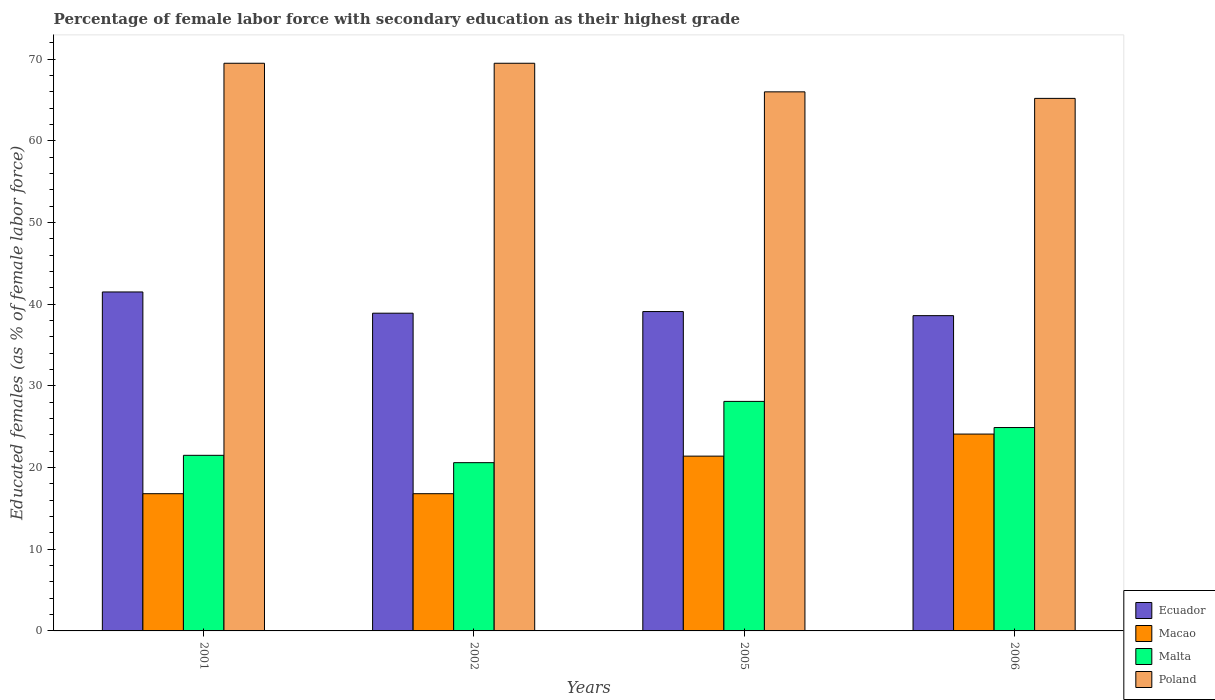How many different coloured bars are there?
Keep it short and to the point. 4. How many groups of bars are there?
Make the answer very short. 4. How many bars are there on the 2nd tick from the left?
Provide a succinct answer. 4. How many bars are there on the 1st tick from the right?
Offer a terse response. 4. What is the percentage of female labor force with secondary education in Ecuador in 2005?
Ensure brevity in your answer.  39.1. Across all years, what is the maximum percentage of female labor force with secondary education in Macao?
Your answer should be compact. 24.1. Across all years, what is the minimum percentage of female labor force with secondary education in Malta?
Your answer should be compact. 20.6. What is the total percentage of female labor force with secondary education in Ecuador in the graph?
Your answer should be compact. 158.1. What is the difference between the percentage of female labor force with secondary education in Poland in 2001 and that in 2002?
Your answer should be compact. 0. What is the difference between the percentage of female labor force with secondary education in Malta in 2005 and the percentage of female labor force with secondary education in Poland in 2001?
Make the answer very short. -41.4. What is the average percentage of female labor force with secondary education in Macao per year?
Make the answer very short. 19.77. In the year 2006, what is the difference between the percentage of female labor force with secondary education in Poland and percentage of female labor force with secondary education in Ecuador?
Offer a very short reply. 26.6. In how many years, is the percentage of female labor force with secondary education in Malta greater than 24 %?
Your answer should be compact. 2. What is the ratio of the percentage of female labor force with secondary education in Malta in 2002 to that in 2005?
Offer a very short reply. 0.73. What is the difference between the highest and the second highest percentage of female labor force with secondary education in Macao?
Ensure brevity in your answer.  2.7. What is the difference between the highest and the lowest percentage of female labor force with secondary education in Ecuador?
Your answer should be very brief. 2.9. Is the sum of the percentage of female labor force with secondary education in Malta in 2001 and 2002 greater than the maximum percentage of female labor force with secondary education in Macao across all years?
Ensure brevity in your answer.  Yes. Is it the case that in every year, the sum of the percentage of female labor force with secondary education in Macao and percentage of female labor force with secondary education in Poland is greater than the sum of percentage of female labor force with secondary education in Ecuador and percentage of female labor force with secondary education in Malta?
Give a very brief answer. Yes. What does the 1st bar from the left in 2001 represents?
Give a very brief answer. Ecuador. What does the 1st bar from the right in 2005 represents?
Provide a short and direct response. Poland. How many bars are there?
Ensure brevity in your answer.  16. Are all the bars in the graph horizontal?
Make the answer very short. No. How many years are there in the graph?
Keep it short and to the point. 4. What is the difference between two consecutive major ticks on the Y-axis?
Your response must be concise. 10. Where does the legend appear in the graph?
Make the answer very short. Bottom right. How are the legend labels stacked?
Ensure brevity in your answer.  Vertical. What is the title of the graph?
Make the answer very short. Percentage of female labor force with secondary education as their highest grade. What is the label or title of the X-axis?
Offer a very short reply. Years. What is the label or title of the Y-axis?
Your response must be concise. Educated females (as % of female labor force). What is the Educated females (as % of female labor force) of Ecuador in 2001?
Make the answer very short. 41.5. What is the Educated females (as % of female labor force) in Macao in 2001?
Your answer should be compact. 16.8. What is the Educated females (as % of female labor force) of Malta in 2001?
Offer a very short reply. 21.5. What is the Educated females (as % of female labor force) of Poland in 2001?
Your response must be concise. 69.5. What is the Educated females (as % of female labor force) in Ecuador in 2002?
Your response must be concise. 38.9. What is the Educated females (as % of female labor force) in Macao in 2002?
Make the answer very short. 16.8. What is the Educated females (as % of female labor force) in Malta in 2002?
Keep it short and to the point. 20.6. What is the Educated females (as % of female labor force) of Poland in 2002?
Provide a succinct answer. 69.5. What is the Educated females (as % of female labor force) of Ecuador in 2005?
Offer a very short reply. 39.1. What is the Educated females (as % of female labor force) in Macao in 2005?
Offer a terse response. 21.4. What is the Educated females (as % of female labor force) in Malta in 2005?
Give a very brief answer. 28.1. What is the Educated females (as % of female labor force) of Poland in 2005?
Offer a very short reply. 66. What is the Educated females (as % of female labor force) of Ecuador in 2006?
Give a very brief answer. 38.6. What is the Educated females (as % of female labor force) in Macao in 2006?
Your response must be concise. 24.1. What is the Educated females (as % of female labor force) of Malta in 2006?
Provide a succinct answer. 24.9. What is the Educated females (as % of female labor force) of Poland in 2006?
Ensure brevity in your answer.  65.2. Across all years, what is the maximum Educated females (as % of female labor force) of Ecuador?
Your answer should be very brief. 41.5. Across all years, what is the maximum Educated females (as % of female labor force) of Macao?
Make the answer very short. 24.1. Across all years, what is the maximum Educated females (as % of female labor force) of Malta?
Offer a terse response. 28.1. Across all years, what is the maximum Educated females (as % of female labor force) in Poland?
Provide a succinct answer. 69.5. Across all years, what is the minimum Educated females (as % of female labor force) in Ecuador?
Provide a succinct answer. 38.6. Across all years, what is the minimum Educated females (as % of female labor force) in Macao?
Provide a short and direct response. 16.8. Across all years, what is the minimum Educated females (as % of female labor force) of Malta?
Your answer should be compact. 20.6. Across all years, what is the minimum Educated females (as % of female labor force) in Poland?
Offer a terse response. 65.2. What is the total Educated females (as % of female labor force) in Ecuador in the graph?
Provide a succinct answer. 158.1. What is the total Educated females (as % of female labor force) in Macao in the graph?
Keep it short and to the point. 79.1. What is the total Educated females (as % of female labor force) in Malta in the graph?
Your answer should be very brief. 95.1. What is the total Educated females (as % of female labor force) of Poland in the graph?
Offer a very short reply. 270.2. What is the difference between the Educated females (as % of female labor force) in Ecuador in 2001 and that in 2005?
Your answer should be compact. 2.4. What is the difference between the Educated females (as % of female labor force) of Malta in 2001 and that in 2005?
Your answer should be very brief. -6.6. What is the difference between the Educated females (as % of female labor force) in Poland in 2001 and that in 2005?
Your response must be concise. 3.5. What is the difference between the Educated females (as % of female labor force) in Ecuador in 2001 and that in 2006?
Provide a succinct answer. 2.9. What is the difference between the Educated females (as % of female labor force) in Poland in 2001 and that in 2006?
Make the answer very short. 4.3. What is the difference between the Educated females (as % of female labor force) in Macao in 2002 and that in 2005?
Your response must be concise. -4.6. What is the difference between the Educated females (as % of female labor force) in Malta in 2002 and that in 2005?
Offer a very short reply. -7.5. What is the difference between the Educated females (as % of female labor force) of Macao in 2002 and that in 2006?
Offer a very short reply. -7.3. What is the difference between the Educated females (as % of female labor force) of Ecuador in 2005 and that in 2006?
Make the answer very short. 0.5. What is the difference between the Educated females (as % of female labor force) of Macao in 2005 and that in 2006?
Make the answer very short. -2.7. What is the difference between the Educated females (as % of female labor force) of Poland in 2005 and that in 2006?
Offer a terse response. 0.8. What is the difference between the Educated females (as % of female labor force) of Ecuador in 2001 and the Educated females (as % of female labor force) of Macao in 2002?
Ensure brevity in your answer.  24.7. What is the difference between the Educated females (as % of female labor force) in Ecuador in 2001 and the Educated females (as % of female labor force) in Malta in 2002?
Your answer should be very brief. 20.9. What is the difference between the Educated females (as % of female labor force) of Ecuador in 2001 and the Educated females (as % of female labor force) of Poland in 2002?
Keep it short and to the point. -28. What is the difference between the Educated females (as % of female labor force) in Macao in 2001 and the Educated females (as % of female labor force) in Malta in 2002?
Make the answer very short. -3.8. What is the difference between the Educated females (as % of female labor force) in Macao in 2001 and the Educated females (as % of female labor force) in Poland in 2002?
Offer a very short reply. -52.7. What is the difference between the Educated females (as % of female labor force) in Malta in 2001 and the Educated females (as % of female labor force) in Poland in 2002?
Provide a succinct answer. -48. What is the difference between the Educated females (as % of female labor force) in Ecuador in 2001 and the Educated females (as % of female labor force) in Macao in 2005?
Give a very brief answer. 20.1. What is the difference between the Educated females (as % of female labor force) in Ecuador in 2001 and the Educated females (as % of female labor force) in Poland in 2005?
Your response must be concise. -24.5. What is the difference between the Educated females (as % of female labor force) in Macao in 2001 and the Educated females (as % of female labor force) in Malta in 2005?
Provide a succinct answer. -11.3. What is the difference between the Educated females (as % of female labor force) of Macao in 2001 and the Educated females (as % of female labor force) of Poland in 2005?
Provide a short and direct response. -49.2. What is the difference between the Educated females (as % of female labor force) in Malta in 2001 and the Educated females (as % of female labor force) in Poland in 2005?
Provide a succinct answer. -44.5. What is the difference between the Educated females (as % of female labor force) of Ecuador in 2001 and the Educated females (as % of female labor force) of Malta in 2006?
Your response must be concise. 16.6. What is the difference between the Educated females (as % of female labor force) in Ecuador in 2001 and the Educated females (as % of female labor force) in Poland in 2006?
Provide a succinct answer. -23.7. What is the difference between the Educated females (as % of female labor force) of Macao in 2001 and the Educated females (as % of female labor force) of Malta in 2006?
Provide a short and direct response. -8.1. What is the difference between the Educated females (as % of female labor force) of Macao in 2001 and the Educated females (as % of female labor force) of Poland in 2006?
Provide a short and direct response. -48.4. What is the difference between the Educated females (as % of female labor force) of Malta in 2001 and the Educated females (as % of female labor force) of Poland in 2006?
Provide a short and direct response. -43.7. What is the difference between the Educated females (as % of female labor force) in Ecuador in 2002 and the Educated females (as % of female labor force) in Poland in 2005?
Provide a short and direct response. -27.1. What is the difference between the Educated females (as % of female labor force) of Macao in 2002 and the Educated females (as % of female labor force) of Malta in 2005?
Keep it short and to the point. -11.3. What is the difference between the Educated females (as % of female labor force) in Macao in 2002 and the Educated females (as % of female labor force) in Poland in 2005?
Offer a very short reply. -49.2. What is the difference between the Educated females (as % of female labor force) in Malta in 2002 and the Educated females (as % of female labor force) in Poland in 2005?
Offer a very short reply. -45.4. What is the difference between the Educated females (as % of female labor force) of Ecuador in 2002 and the Educated females (as % of female labor force) of Macao in 2006?
Provide a succinct answer. 14.8. What is the difference between the Educated females (as % of female labor force) of Ecuador in 2002 and the Educated females (as % of female labor force) of Malta in 2006?
Your answer should be compact. 14. What is the difference between the Educated females (as % of female labor force) in Ecuador in 2002 and the Educated females (as % of female labor force) in Poland in 2006?
Ensure brevity in your answer.  -26.3. What is the difference between the Educated females (as % of female labor force) of Macao in 2002 and the Educated females (as % of female labor force) of Malta in 2006?
Offer a terse response. -8.1. What is the difference between the Educated females (as % of female labor force) in Macao in 2002 and the Educated females (as % of female labor force) in Poland in 2006?
Ensure brevity in your answer.  -48.4. What is the difference between the Educated females (as % of female labor force) of Malta in 2002 and the Educated females (as % of female labor force) of Poland in 2006?
Give a very brief answer. -44.6. What is the difference between the Educated females (as % of female labor force) in Ecuador in 2005 and the Educated females (as % of female labor force) in Macao in 2006?
Ensure brevity in your answer.  15. What is the difference between the Educated females (as % of female labor force) of Ecuador in 2005 and the Educated females (as % of female labor force) of Poland in 2006?
Ensure brevity in your answer.  -26.1. What is the difference between the Educated females (as % of female labor force) of Macao in 2005 and the Educated females (as % of female labor force) of Poland in 2006?
Keep it short and to the point. -43.8. What is the difference between the Educated females (as % of female labor force) in Malta in 2005 and the Educated females (as % of female labor force) in Poland in 2006?
Make the answer very short. -37.1. What is the average Educated females (as % of female labor force) in Ecuador per year?
Make the answer very short. 39.52. What is the average Educated females (as % of female labor force) in Macao per year?
Offer a very short reply. 19.77. What is the average Educated females (as % of female labor force) in Malta per year?
Your answer should be very brief. 23.77. What is the average Educated females (as % of female labor force) in Poland per year?
Provide a short and direct response. 67.55. In the year 2001, what is the difference between the Educated females (as % of female labor force) of Ecuador and Educated females (as % of female labor force) of Macao?
Offer a terse response. 24.7. In the year 2001, what is the difference between the Educated females (as % of female labor force) of Ecuador and Educated females (as % of female labor force) of Malta?
Your response must be concise. 20. In the year 2001, what is the difference between the Educated females (as % of female labor force) of Ecuador and Educated females (as % of female labor force) of Poland?
Offer a very short reply. -28. In the year 2001, what is the difference between the Educated females (as % of female labor force) of Macao and Educated females (as % of female labor force) of Malta?
Offer a terse response. -4.7. In the year 2001, what is the difference between the Educated females (as % of female labor force) of Macao and Educated females (as % of female labor force) of Poland?
Make the answer very short. -52.7. In the year 2001, what is the difference between the Educated females (as % of female labor force) in Malta and Educated females (as % of female labor force) in Poland?
Provide a succinct answer. -48. In the year 2002, what is the difference between the Educated females (as % of female labor force) of Ecuador and Educated females (as % of female labor force) of Macao?
Your answer should be very brief. 22.1. In the year 2002, what is the difference between the Educated females (as % of female labor force) in Ecuador and Educated females (as % of female labor force) in Malta?
Provide a short and direct response. 18.3. In the year 2002, what is the difference between the Educated females (as % of female labor force) of Ecuador and Educated females (as % of female labor force) of Poland?
Keep it short and to the point. -30.6. In the year 2002, what is the difference between the Educated females (as % of female labor force) of Macao and Educated females (as % of female labor force) of Poland?
Offer a terse response. -52.7. In the year 2002, what is the difference between the Educated females (as % of female labor force) of Malta and Educated females (as % of female labor force) of Poland?
Offer a terse response. -48.9. In the year 2005, what is the difference between the Educated females (as % of female labor force) in Ecuador and Educated females (as % of female labor force) in Macao?
Your answer should be very brief. 17.7. In the year 2005, what is the difference between the Educated females (as % of female labor force) of Ecuador and Educated females (as % of female labor force) of Poland?
Give a very brief answer. -26.9. In the year 2005, what is the difference between the Educated females (as % of female labor force) in Macao and Educated females (as % of female labor force) in Malta?
Ensure brevity in your answer.  -6.7. In the year 2005, what is the difference between the Educated females (as % of female labor force) of Macao and Educated females (as % of female labor force) of Poland?
Provide a succinct answer. -44.6. In the year 2005, what is the difference between the Educated females (as % of female labor force) of Malta and Educated females (as % of female labor force) of Poland?
Make the answer very short. -37.9. In the year 2006, what is the difference between the Educated females (as % of female labor force) of Ecuador and Educated females (as % of female labor force) of Malta?
Your answer should be very brief. 13.7. In the year 2006, what is the difference between the Educated females (as % of female labor force) in Ecuador and Educated females (as % of female labor force) in Poland?
Provide a short and direct response. -26.6. In the year 2006, what is the difference between the Educated females (as % of female labor force) in Macao and Educated females (as % of female labor force) in Malta?
Ensure brevity in your answer.  -0.8. In the year 2006, what is the difference between the Educated females (as % of female labor force) of Macao and Educated females (as % of female labor force) of Poland?
Offer a very short reply. -41.1. In the year 2006, what is the difference between the Educated females (as % of female labor force) in Malta and Educated females (as % of female labor force) in Poland?
Your answer should be very brief. -40.3. What is the ratio of the Educated females (as % of female labor force) in Ecuador in 2001 to that in 2002?
Your answer should be compact. 1.07. What is the ratio of the Educated females (as % of female labor force) in Malta in 2001 to that in 2002?
Your response must be concise. 1.04. What is the ratio of the Educated females (as % of female labor force) of Ecuador in 2001 to that in 2005?
Offer a terse response. 1.06. What is the ratio of the Educated females (as % of female labor force) in Macao in 2001 to that in 2005?
Provide a succinct answer. 0.79. What is the ratio of the Educated females (as % of female labor force) in Malta in 2001 to that in 2005?
Provide a short and direct response. 0.77. What is the ratio of the Educated females (as % of female labor force) of Poland in 2001 to that in 2005?
Give a very brief answer. 1.05. What is the ratio of the Educated females (as % of female labor force) in Ecuador in 2001 to that in 2006?
Make the answer very short. 1.08. What is the ratio of the Educated females (as % of female labor force) in Macao in 2001 to that in 2006?
Provide a short and direct response. 0.7. What is the ratio of the Educated females (as % of female labor force) of Malta in 2001 to that in 2006?
Your response must be concise. 0.86. What is the ratio of the Educated females (as % of female labor force) in Poland in 2001 to that in 2006?
Ensure brevity in your answer.  1.07. What is the ratio of the Educated females (as % of female labor force) in Ecuador in 2002 to that in 2005?
Make the answer very short. 0.99. What is the ratio of the Educated females (as % of female labor force) in Macao in 2002 to that in 2005?
Provide a short and direct response. 0.79. What is the ratio of the Educated females (as % of female labor force) in Malta in 2002 to that in 2005?
Provide a short and direct response. 0.73. What is the ratio of the Educated females (as % of female labor force) in Poland in 2002 to that in 2005?
Your response must be concise. 1.05. What is the ratio of the Educated females (as % of female labor force) in Macao in 2002 to that in 2006?
Ensure brevity in your answer.  0.7. What is the ratio of the Educated females (as % of female labor force) of Malta in 2002 to that in 2006?
Your response must be concise. 0.83. What is the ratio of the Educated females (as % of female labor force) of Poland in 2002 to that in 2006?
Ensure brevity in your answer.  1.07. What is the ratio of the Educated females (as % of female labor force) of Macao in 2005 to that in 2006?
Your answer should be compact. 0.89. What is the ratio of the Educated females (as % of female labor force) in Malta in 2005 to that in 2006?
Provide a succinct answer. 1.13. What is the ratio of the Educated females (as % of female labor force) in Poland in 2005 to that in 2006?
Your answer should be very brief. 1.01. What is the difference between the highest and the second highest Educated females (as % of female labor force) of Ecuador?
Provide a succinct answer. 2.4. What is the difference between the highest and the second highest Educated females (as % of female labor force) of Macao?
Offer a very short reply. 2.7. What is the difference between the highest and the second highest Educated females (as % of female labor force) in Malta?
Keep it short and to the point. 3.2. What is the difference between the highest and the lowest Educated females (as % of female labor force) of Poland?
Offer a very short reply. 4.3. 